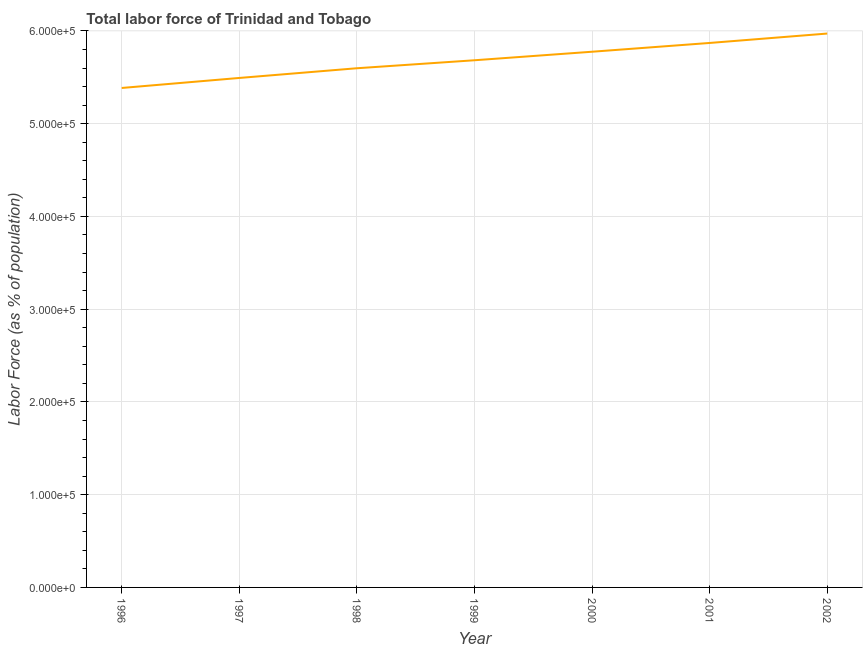What is the total labor force in 2001?
Your response must be concise. 5.87e+05. Across all years, what is the maximum total labor force?
Make the answer very short. 5.97e+05. Across all years, what is the minimum total labor force?
Give a very brief answer. 5.38e+05. In which year was the total labor force maximum?
Provide a short and direct response. 2002. In which year was the total labor force minimum?
Provide a succinct answer. 1996. What is the sum of the total labor force?
Offer a terse response. 3.98e+06. What is the difference between the total labor force in 1999 and 2002?
Provide a succinct answer. -2.88e+04. What is the average total labor force per year?
Offer a very short reply. 5.68e+05. What is the median total labor force?
Offer a very short reply. 5.68e+05. Do a majority of the years between 2001 and 1996 (inclusive) have total labor force greater than 320000 %?
Offer a very short reply. Yes. What is the ratio of the total labor force in 1997 to that in 1998?
Your answer should be very brief. 0.98. Is the total labor force in 1997 less than that in 1998?
Provide a short and direct response. Yes. Is the difference between the total labor force in 1999 and 2000 greater than the difference between any two years?
Your response must be concise. No. What is the difference between the highest and the second highest total labor force?
Give a very brief answer. 1.01e+04. What is the difference between the highest and the lowest total labor force?
Ensure brevity in your answer.  5.87e+04. In how many years, is the total labor force greater than the average total labor force taken over all years?
Ensure brevity in your answer.  4. Does the total labor force monotonically increase over the years?
Your response must be concise. Yes. What is the difference between two consecutive major ticks on the Y-axis?
Ensure brevity in your answer.  1.00e+05. Are the values on the major ticks of Y-axis written in scientific E-notation?
Provide a short and direct response. Yes. Does the graph contain any zero values?
Your response must be concise. No. What is the title of the graph?
Offer a terse response. Total labor force of Trinidad and Tobago. What is the label or title of the X-axis?
Your response must be concise. Year. What is the label or title of the Y-axis?
Your answer should be compact. Labor Force (as % of population). What is the Labor Force (as % of population) in 1996?
Provide a succinct answer. 5.38e+05. What is the Labor Force (as % of population) in 1997?
Your answer should be very brief. 5.49e+05. What is the Labor Force (as % of population) in 1998?
Your answer should be very brief. 5.60e+05. What is the Labor Force (as % of population) of 1999?
Ensure brevity in your answer.  5.68e+05. What is the Labor Force (as % of population) in 2000?
Ensure brevity in your answer.  5.78e+05. What is the Labor Force (as % of population) in 2001?
Your answer should be compact. 5.87e+05. What is the Labor Force (as % of population) of 2002?
Your answer should be compact. 5.97e+05. What is the difference between the Labor Force (as % of population) in 1996 and 1997?
Keep it short and to the point. -1.08e+04. What is the difference between the Labor Force (as % of population) in 1996 and 1998?
Your answer should be very brief. -2.13e+04. What is the difference between the Labor Force (as % of population) in 1996 and 1999?
Your answer should be very brief. -2.99e+04. What is the difference between the Labor Force (as % of population) in 1996 and 2000?
Keep it short and to the point. -3.91e+04. What is the difference between the Labor Force (as % of population) in 1996 and 2001?
Ensure brevity in your answer.  -4.85e+04. What is the difference between the Labor Force (as % of population) in 1996 and 2002?
Ensure brevity in your answer.  -5.87e+04. What is the difference between the Labor Force (as % of population) in 1997 and 1998?
Offer a terse response. -1.05e+04. What is the difference between the Labor Force (as % of population) in 1997 and 1999?
Provide a short and direct response. -1.91e+04. What is the difference between the Labor Force (as % of population) in 1997 and 2000?
Your answer should be compact. -2.83e+04. What is the difference between the Labor Force (as % of population) in 1997 and 2001?
Offer a very short reply. -3.77e+04. What is the difference between the Labor Force (as % of population) in 1997 and 2002?
Ensure brevity in your answer.  -4.79e+04. What is the difference between the Labor Force (as % of population) in 1998 and 1999?
Ensure brevity in your answer.  -8612. What is the difference between the Labor Force (as % of population) in 1998 and 2000?
Your answer should be compact. -1.78e+04. What is the difference between the Labor Force (as % of population) in 1998 and 2001?
Your answer should be compact. -2.73e+04. What is the difference between the Labor Force (as % of population) in 1998 and 2002?
Your answer should be compact. -3.74e+04. What is the difference between the Labor Force (as % of population) in 1999 and 2000?
Give a very brief answer. -9186. What is the difference between the Labor Force (as % of population) in 1999 and 2001?
Your answer should be very brief. -1.87e+04. What is the difference between the Labor Force (as % of population) in 1999 and 2002?
Provide a short and direct response. -2.88e+04. What is the difference between the Labor Force (as % of population) in 2000 and 2001?
Make the answer very short. -9467. What is the difference between the Labor Force (as % of population) in 2000 and 2002?
Keep it short and to the point. -1.96e+04. What is the difference between the Labor Force (as % of population) in 2001 and 2002?
Give a very brief answer. -1.01e+04. What is the ratio of the Labor Force (as % of population) in 1996 to that in 1998?
Your answer should be very brief. 0.96. What is the ratio of the Labor Force (as % of population) in 1996 to that in 1999?
Your answer should be compact. 0.95. What is the ratio of the Labor Force (as % of population) in 1996 to that in 2000?
Give a very brief answer. 0.93. What is the ratio of the Labor Force (as % of population) in 1996 to that in 2001?
Provide a short and direct response. 0.92. What is the ratio of the Labor Force (as % of population) in 1996 to that in 2002?
Offer a very short reply. 0.9. What is the ratio of the Labor Force (as % of population) in 1997 to that in 1998?
Provide a succinct answer. 0.98. What is the ratio of the Labor Force (as % of population) in 1997 to that in 1999?
Provide a short and direct response. 0.97. What is the ratio of the Labor Force (as % of population) in 1997 to that in 2000?
Offer a terse response. 0.95. What is the ratio of the Labor Force (as % of population) in 1997 to that in 2001?
Give a very brief answer. 0.94. What is the ratio of the Labor Force (as % of population) in 1998 to that in 2001?
Give a very brief answer. 0.95. What is the ratio of the Labor Force (as % of population) in 1998 to that in 2002?
Provide a short and direct response. 0.94. What is the ratio of the Labor Force (as % of population) in 1999 to that in 2001?
Make the answer very short. 0.97. What is the ratio of the Labor Force (as % of population) in 1999 to that in 2002?
Your answer should be very brief. 0.95. What is the ratio of the Labor Force (as % of population) in 2000 to that in 2001?
Provide a succinct answer. 0.98. What is the ratio of the Labor Force (as % of population) in 2000 to that in 2002?
Provide a short and direct response. 0.97. What is the ratio of the Labor Force (as % of population) in 2001 to that in 2002?
Offer a very short reply. 0.98. 